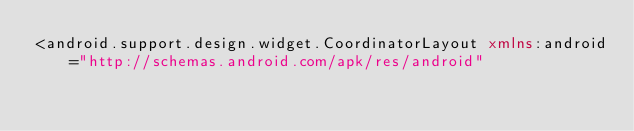<code> <loc_0><loc_0><loc_500><loc_500><_XML_><android.support.design.widget.CoordinatorLayout xmlns:android="http://schemas.android.com/apk/res/android"</code> 